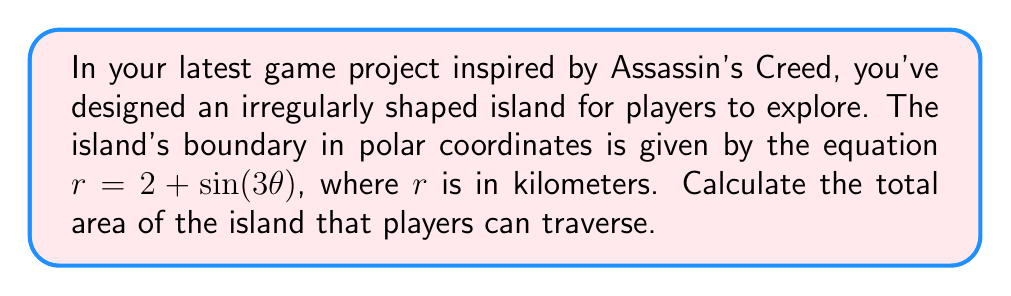Teach me how to tackle this problem. To solve this problem, we'll use polar integration to calculate the area of the irregularly shaped island. Here's a step-by-step approach:

1) The formula for the area of a region in polar coordinates is:

   $$A = \frac{1}{2} \int_0^{2\pi} r^2(\theta) d\theta$$

2) In this case, $r(\theta) = 2 + \sin(3\theta)$. We need to square this function:

   $$r^2(\theta) = (2 + \sin(3\theta))^2 = 4 + 4\sin(3\theta) + \sin^2(3\theta)$$

3) Now, let's set up the integral:

   $$A = \frac{1}{2} \int_0^{2\pi} (4 + 4\sin(3\theta) + \sin^2(3\theta)) d\theta$$

4) Let's integrate each term separately:

   a) $\int_0^{2\pi} 4 d\theta = 4\theta \Big|_0^{2\pi} = 8\pi$

   b) $\int_0^{2\pi} 4\sin(3\theta) d\theta = -\frac{4}{3}\cos(3\theta) \Big|_0^{2\pi} = 0$

   c) For $\int_0^{2\pi} \sin^2(3\theta) d\theta$, we can use the identity $\sin^2 x = \frac{1 - \cos(2x)}{2}$:
      
      $$\int_0^{2\pi} \sin^2(3\theta) d\theta = \int_0^{2\pi} \frac{1 - \cos(6\theta)}{2} d\theta = \frac{\theta}{2} - \frac{\sin(6\theta)}{12} \Big|_0^{2\pi} = \pi$$

5) Adding these results:

   $$A = \frac{1}{2} (8\pi + 0 + \pi) = \frac{9\pi}{2}$$

6) Therefore, the total area of the island is $\frac{9\pi}{2}$ square kilometers.

[asy]
import graph;
size(200);
real r(real t) {return 2+sin(3t);}
path p;
for(real t=0; t<=2pi; t+=0.01) {
  pair z=(r(t)*cos(t),r(t)*sin(t));
  p=p--z;
}
p=p--cycle;
fill(p,palegreen);
draw(p,darkgreen+1);
xaxis(Arrow);
yaxis(Arrow);
label("x (km)",x=3,y=0);
label("y (km)",x=0,y=3);
[/asy]
Answer: $\frac{9\pi}{2}$ square kilometers 